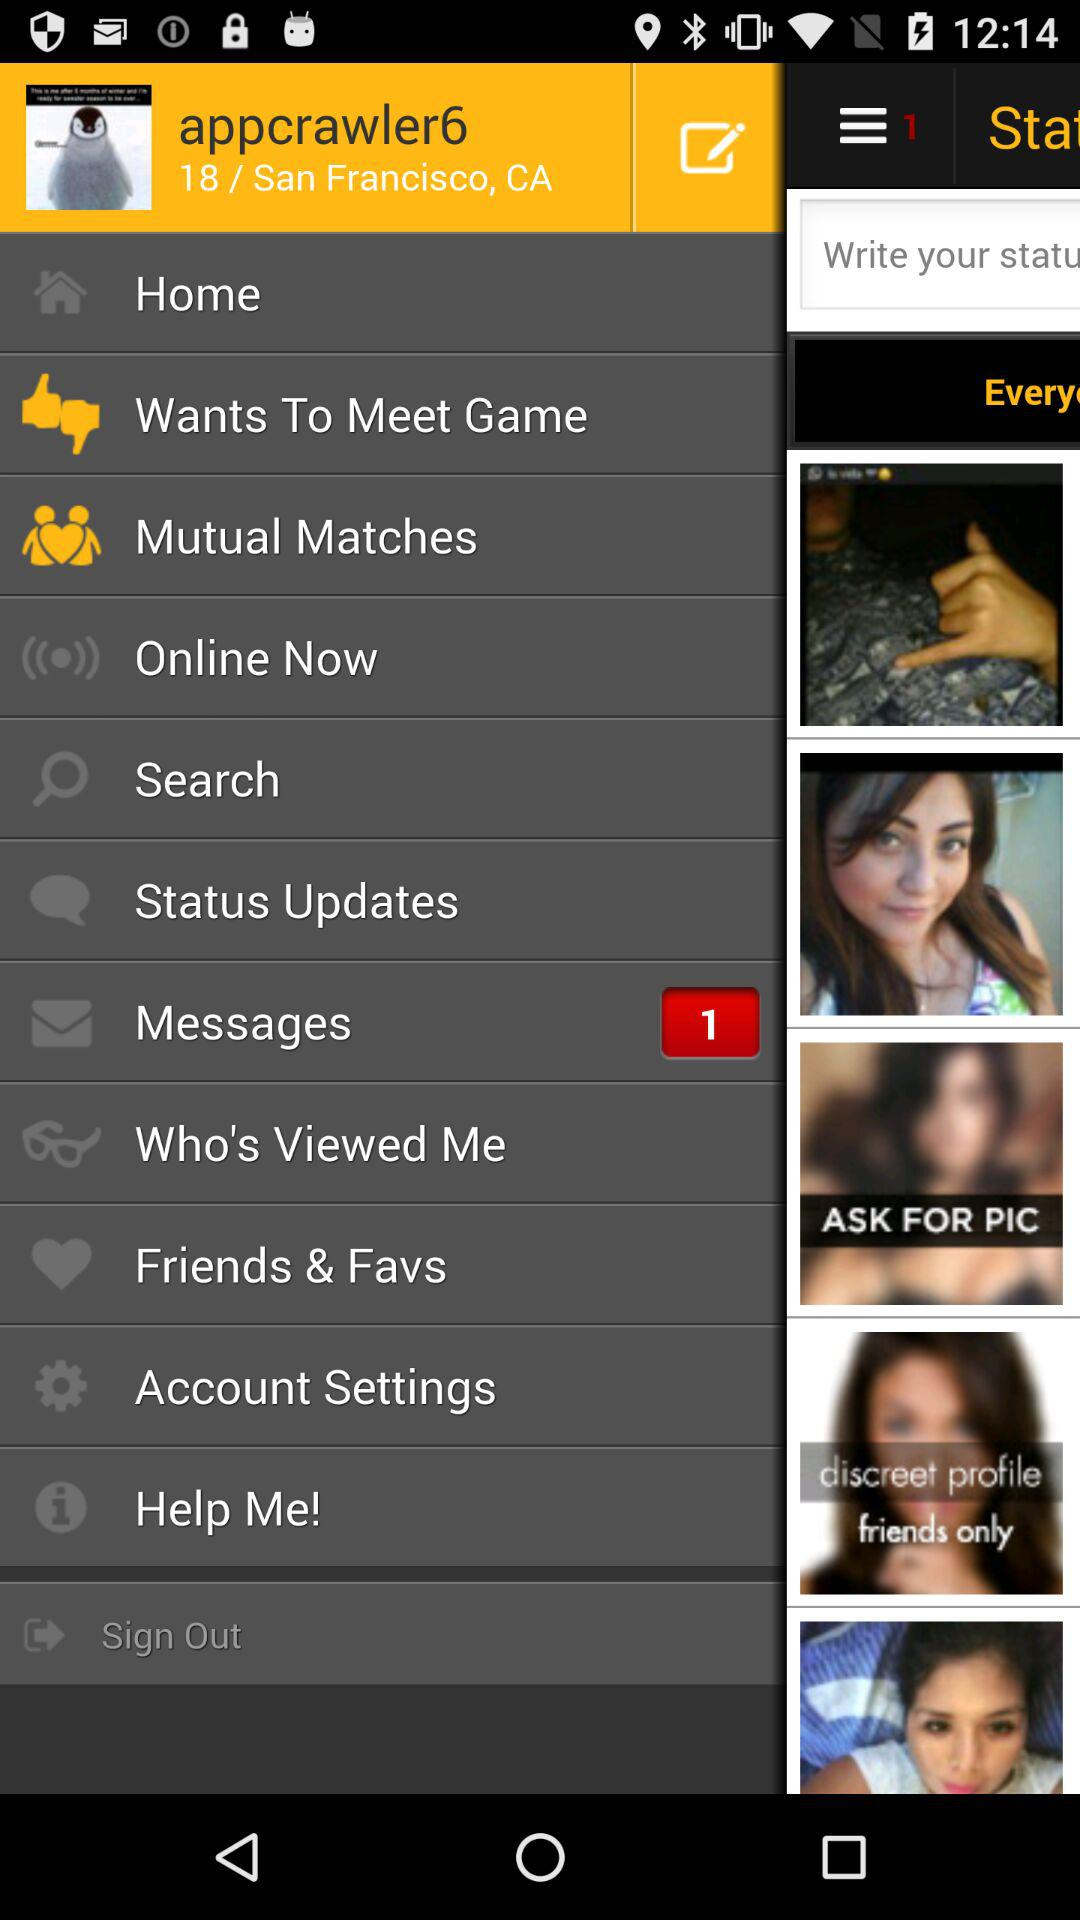What is the country name?
When the provided information is insufficient, respond with <no answer>. <no answer> 